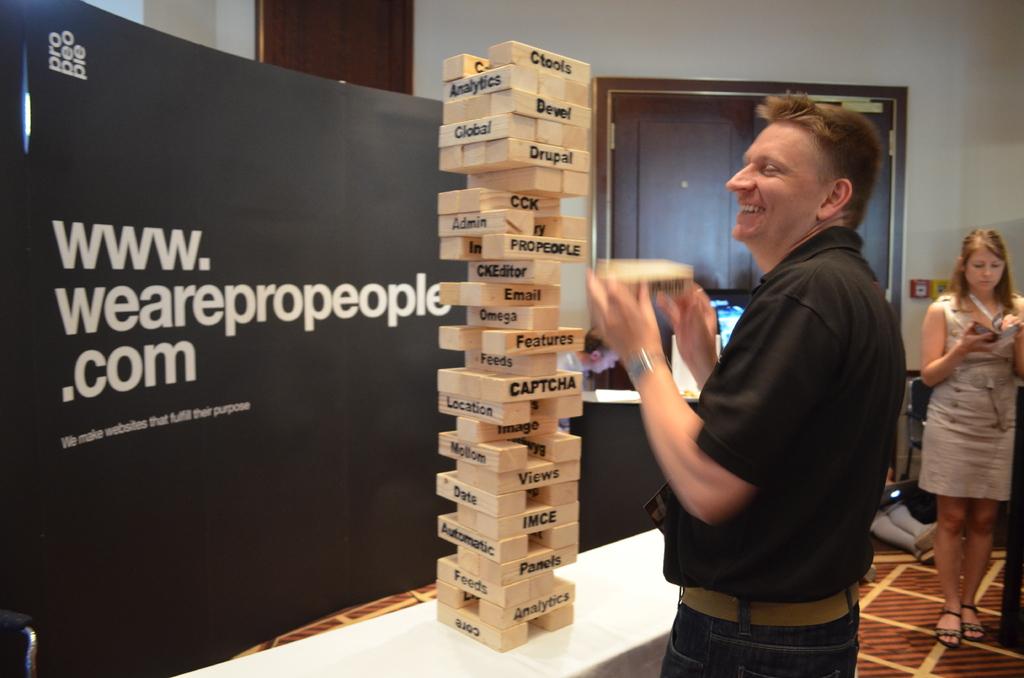What website is on the sign?
Make the answer very short. Www.wearepropeople.com. 